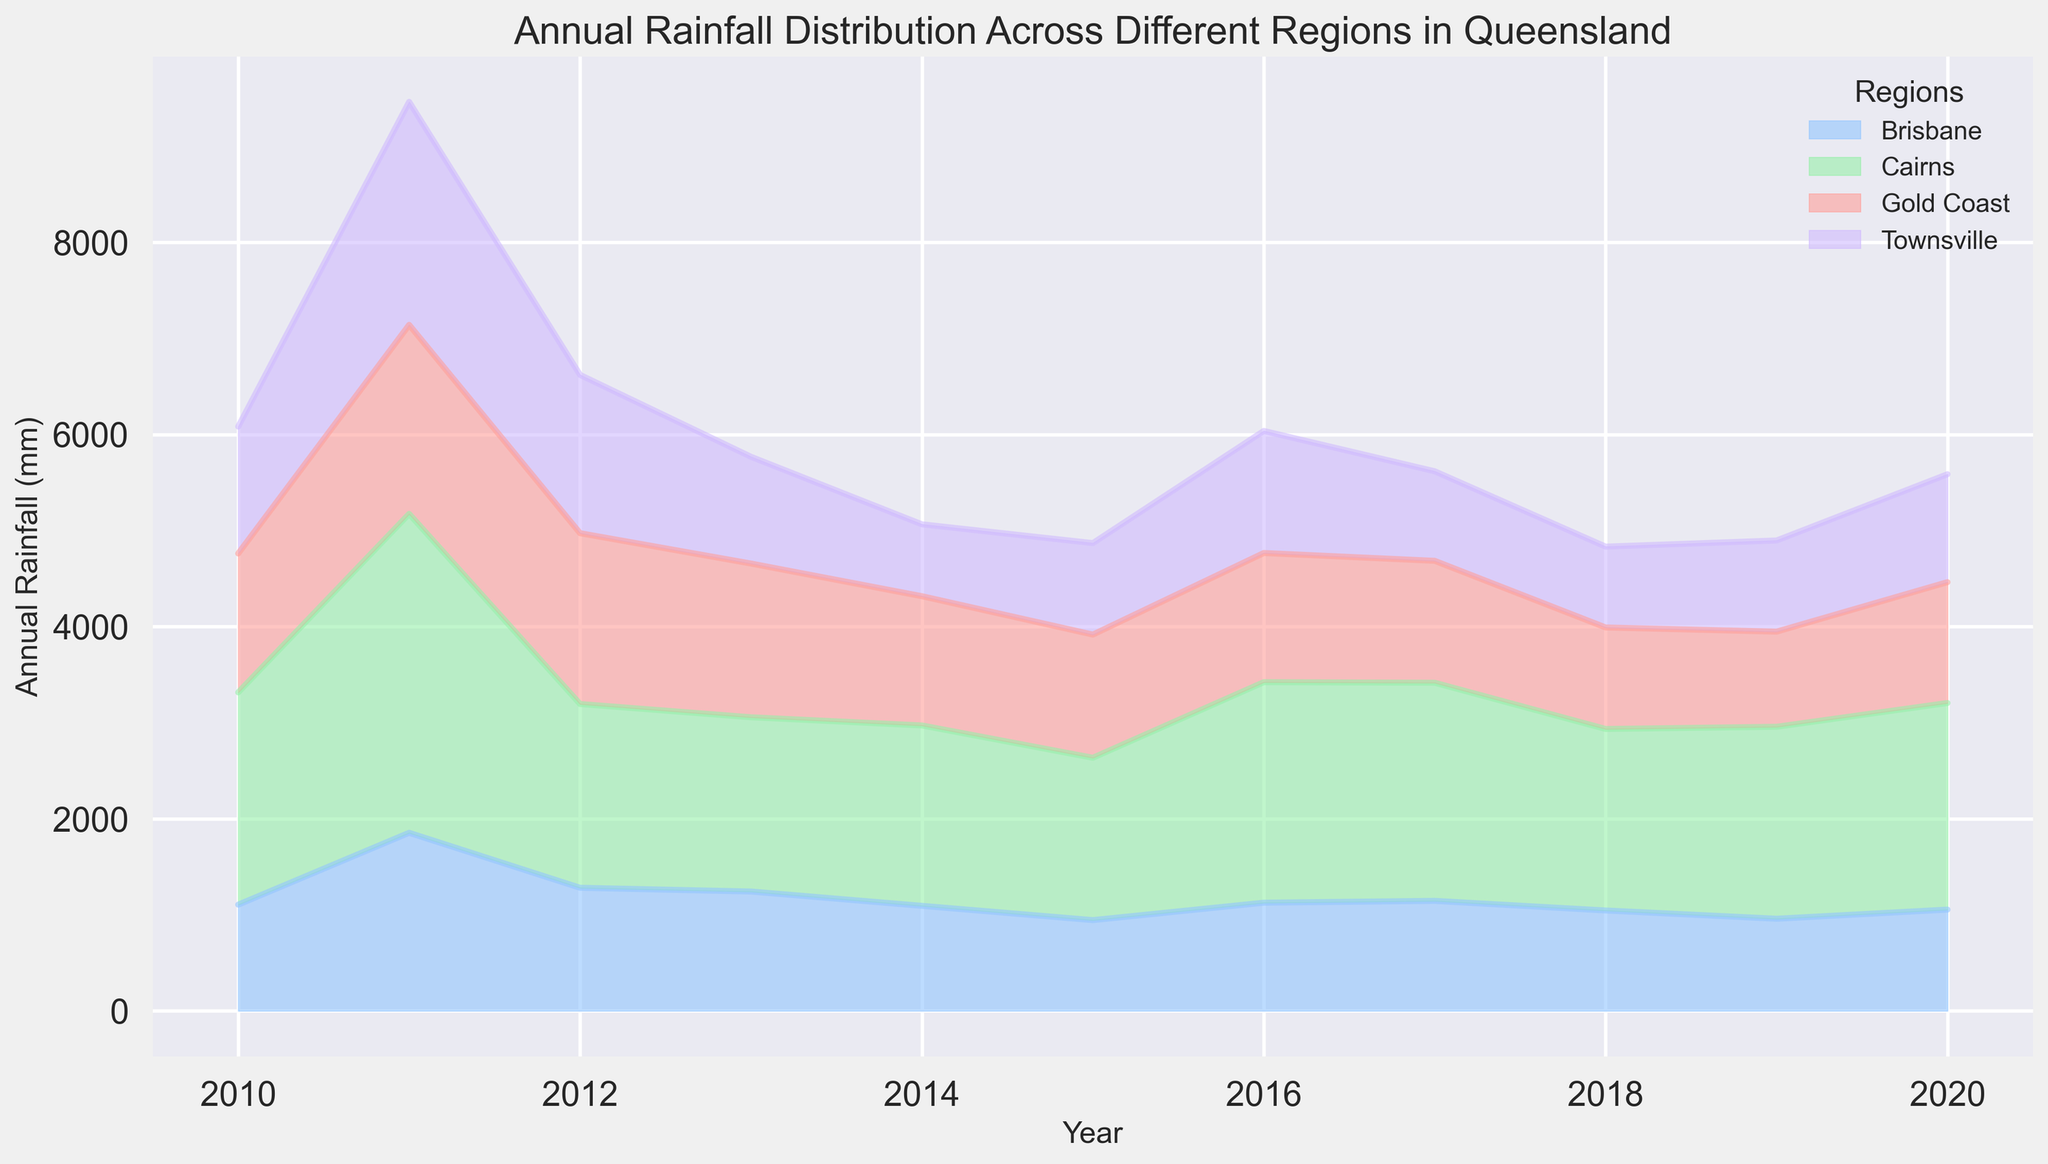Which region had the highest annual rainfall in 2011? Look at the height of the areas representing each region in the year 2011. Cairns has the tallest area, indicating the highest rainfall.
Answer: Cairns Which year did Brisbane experience the least amount of annual rainfall? Check the lowest point of the area representing Brisbane across the X-axis (years). The year with the lowest area height for Brisbane is 2015.
Answer: 2015 Compare the annual rainfall in Gold Coast and Townsville in 2017. Which region had more rainfall? Compare the heights of the areas representing Gold Coast and Townsville in the year 2017. Gold Coast has a slightly higher area than Townsville.
Answer: Gold Coast What is the overall trend in annual rainfall for Brisbane from 2010 to 2020? Observe the area representing Brisbane across the entire X-axis. Despite some fluctuations, the trend is relatively stable without significant increases or decreases.
Answer: Stable Which year had the most significant difference in annual rainfall between Cairns and Townsville? Calculate the visual difference between the areas of Cairns and Townsville for each year and identify the year with the largest difference. The most significant difference is in 2011.
Answer: 2011 What is the approximate sum of annual rainfall for the Gold Coast and Brisbane in 2012? Find the heights of the areas representing Gold Coast and Brisbane in 2012. Gold Coast is around 1777.9 mm and Brisbane is approximately 1281.4 mm. Sum these values: 1777.9 + 1281.4 = 3059.3 mm.
Answer: 3059.3 mm Which region experienced a decrease in annual rainfall from 2013 to 2014? Compare the heights of the areas for each region between 2013 and 2014. Townsville's area is significantly lower in 2014 than in 2013.
Answer: Townsville Between 2010 and 2020, which region had the most frequent fluctuations in annual rainfall? Observe the areas of all regions across the X-axis (years) and identify the region with the most frequent peaks and valleys. Cairns shows frequent and substantial fluctuations.
Answer: Cairns What is the visual trend in annual rainfall for Townsville from 2014 to 2018? Look at the area representing Townsville from 2014 to 2018. The trend shows initially decreasing from 2014 to 2016 and then slightly increasing.
Answer: Decreasing then increasing In which year did Gold Coast and Brisbane have nearly similar amounts of annual rainfall? Compare the areas representing Gold Coast and Brisbane for each year and identify where the height difference is minimal. In 2016, the height difference is quite small.
Answer: 2016 